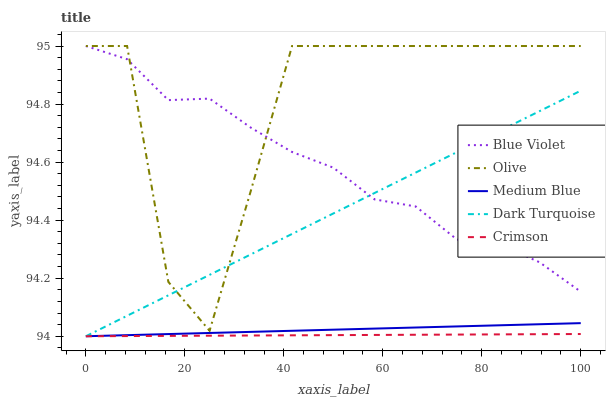Does Crimson have the minimum area under the curve?
Answer yes or no. Yes. Does Olive have the maximum area under the curve?
Answer yes or no. Yes. Does Dark Turquoise have the minimum area under the curve?
Answer yes or no. No. Does Dark Turquoise have the maximum area under the curve?
Answer yes or no. No. Is Medium Blue the smoothest?
Answer yes or no. Yes. Is Olive the roughest?
Answer yes or no. Yes. Is Dark Turquoise the smoothest?
Answer yes or no. No. Is Dark Turquoise the roughest?
Answer yes or no. No. Does Dark Turquoise have the lowest value?
Answer yes or no. Yes. Does Blue Violet have the lowest value?
Answer yes or no. No. Does Blue Violet have the highest value?
Answer yes or no. Yes. Does Dark Turquoise have the highest value?
Answer yes or no. No. Is Crimson less than Blue Violet?
Answer yes or no. Yes. Is Olive greater than Crimson?
Answer yes or no. Yes. Does Dark Turquoise intersect Medium Blue?
Answer yes or no. Yes. Is Dark Turquoise less than Medium Blue?
Answer yes or no. No. Is Dark Turquoise greater than Medium Blue?
Answer yes or no. No. Does Crimson intersect Blue Violet?
Answer yes or no. No. 